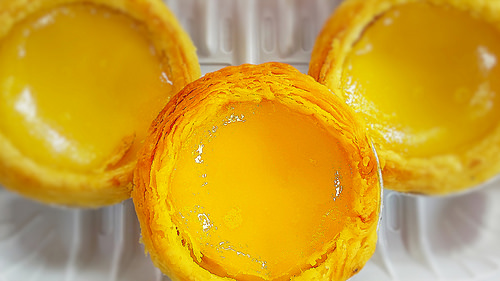<image>
Can you confirm if the treat is above the treat? Yes. The treat is positioned above the treat in the vertical space, higher up in the scene. 